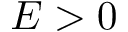Convert formula to latex. <formula><loc_0><loc_0><loc_500><loc_500>E > 0</formula> 